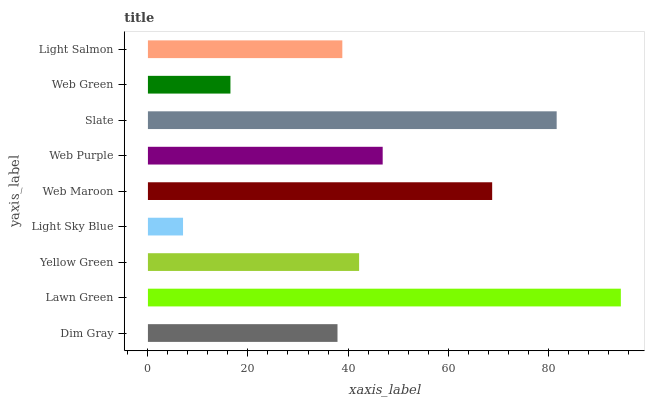Is Light Sky Blue the minimum?
Answer yes or no. Yes. Is Lawn Green the maximum?
Answer yes or no. Yes. Is Yellow Green the minimum?
Answer yes or no. No. Is Yellow Green the maximum?
Answer yes or no. No. Is Lawn Green greater than Yellow Green?
Answer yes or no. Yes. Is Yellow Green less than Lawn Green?
Answer yes or no. Yes. Is Yellow Green greater than Lawn Green?
Answer yes or no. No. Is Lawn Green less than Yellow Green?
Answer yes or no. No. Is Yellow Green the high median?
Answer yes or no. Yes. Is Yellow Green the low median?
Answer yes or no. Yes. Is Light Salmon the high median?
Answer yes or no. No. Is Dim Gray the low median?
Answer yes or no. No. 